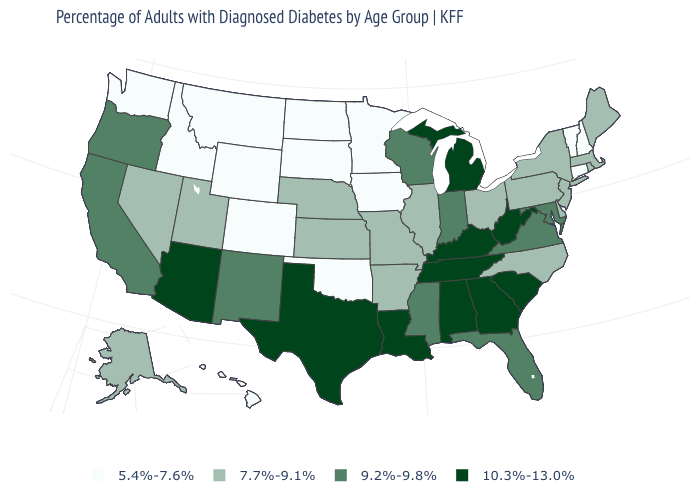Does the map have missing data?
Be succinct. No. What is the value of North Dakota?
Quick response, please. 5.4%-7.6%. Among the states that border Utah , which have the highest value?
Write a very short answer. Arizona. Which states have the lowest value in the West?
Concise answer only. Colorado, Hawaii, Idaho, Montana, Washington, Wyoming. What is the highest value in the MidWest ?
Give a very brief answer. 10.3%-13.0%. What is the lowest value in the USA?
Answer briefly. 5.4%-7.6%. What is the highest value in the USA?
Keep it brief. 10.3%-13.0%. Does West Virginia have the same value as Kentucky?
Concise answer only. Yes. What is the value of Connecticut?
Keep it brief. 5.4%-7.6%. Does Colorado have the lowest value in the USA?
Keep it brief. Yes. Name the states that have a value in the range 9.2%-9.8%?
Concise answer only. California, Florida, Indiana, Maryland, Mississippi, New Mexico, Oregon, Virginia, Wisconsin. Name the states that have a value in the range 9.2%-9.8%?
Concise answer only. California, Florida, Indiana, Maryland, Mississippi, New Mexico, Oregon, Virginia, Wisconsin. Name the states that have a value in the range 9.2%-9.8%?
Short answer required. California, Florida, Indiana, Maryland, Mississippi, New Mexico, Oregon, Virginia, Wisconsin. What is the value of Mississippi?
Short answer required. 9.2%-9.8%. What is the value of Florida?
Short answer required. 9.2%-9.8%. 